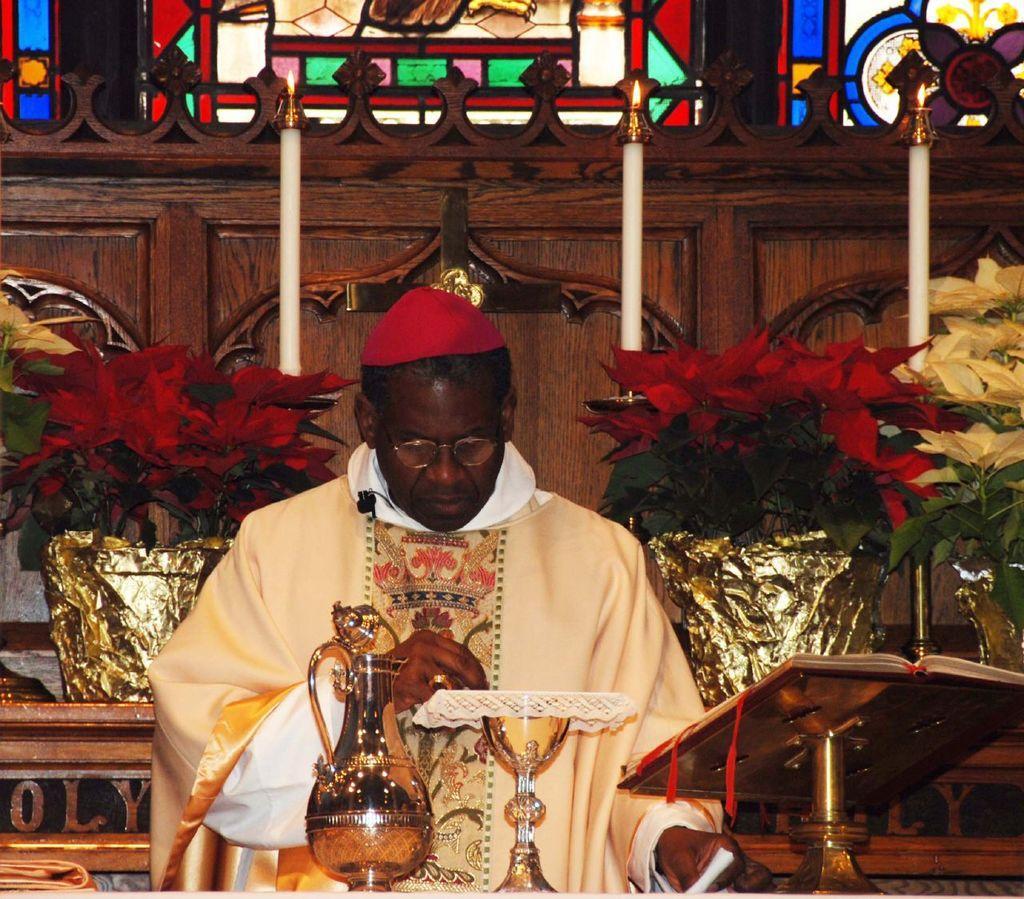How would you summarize this image in a sentence or two? In the middle of the image we can see a glass and jar. Behind them a man is standing. Behind the man there are some plants and candles and wall. 